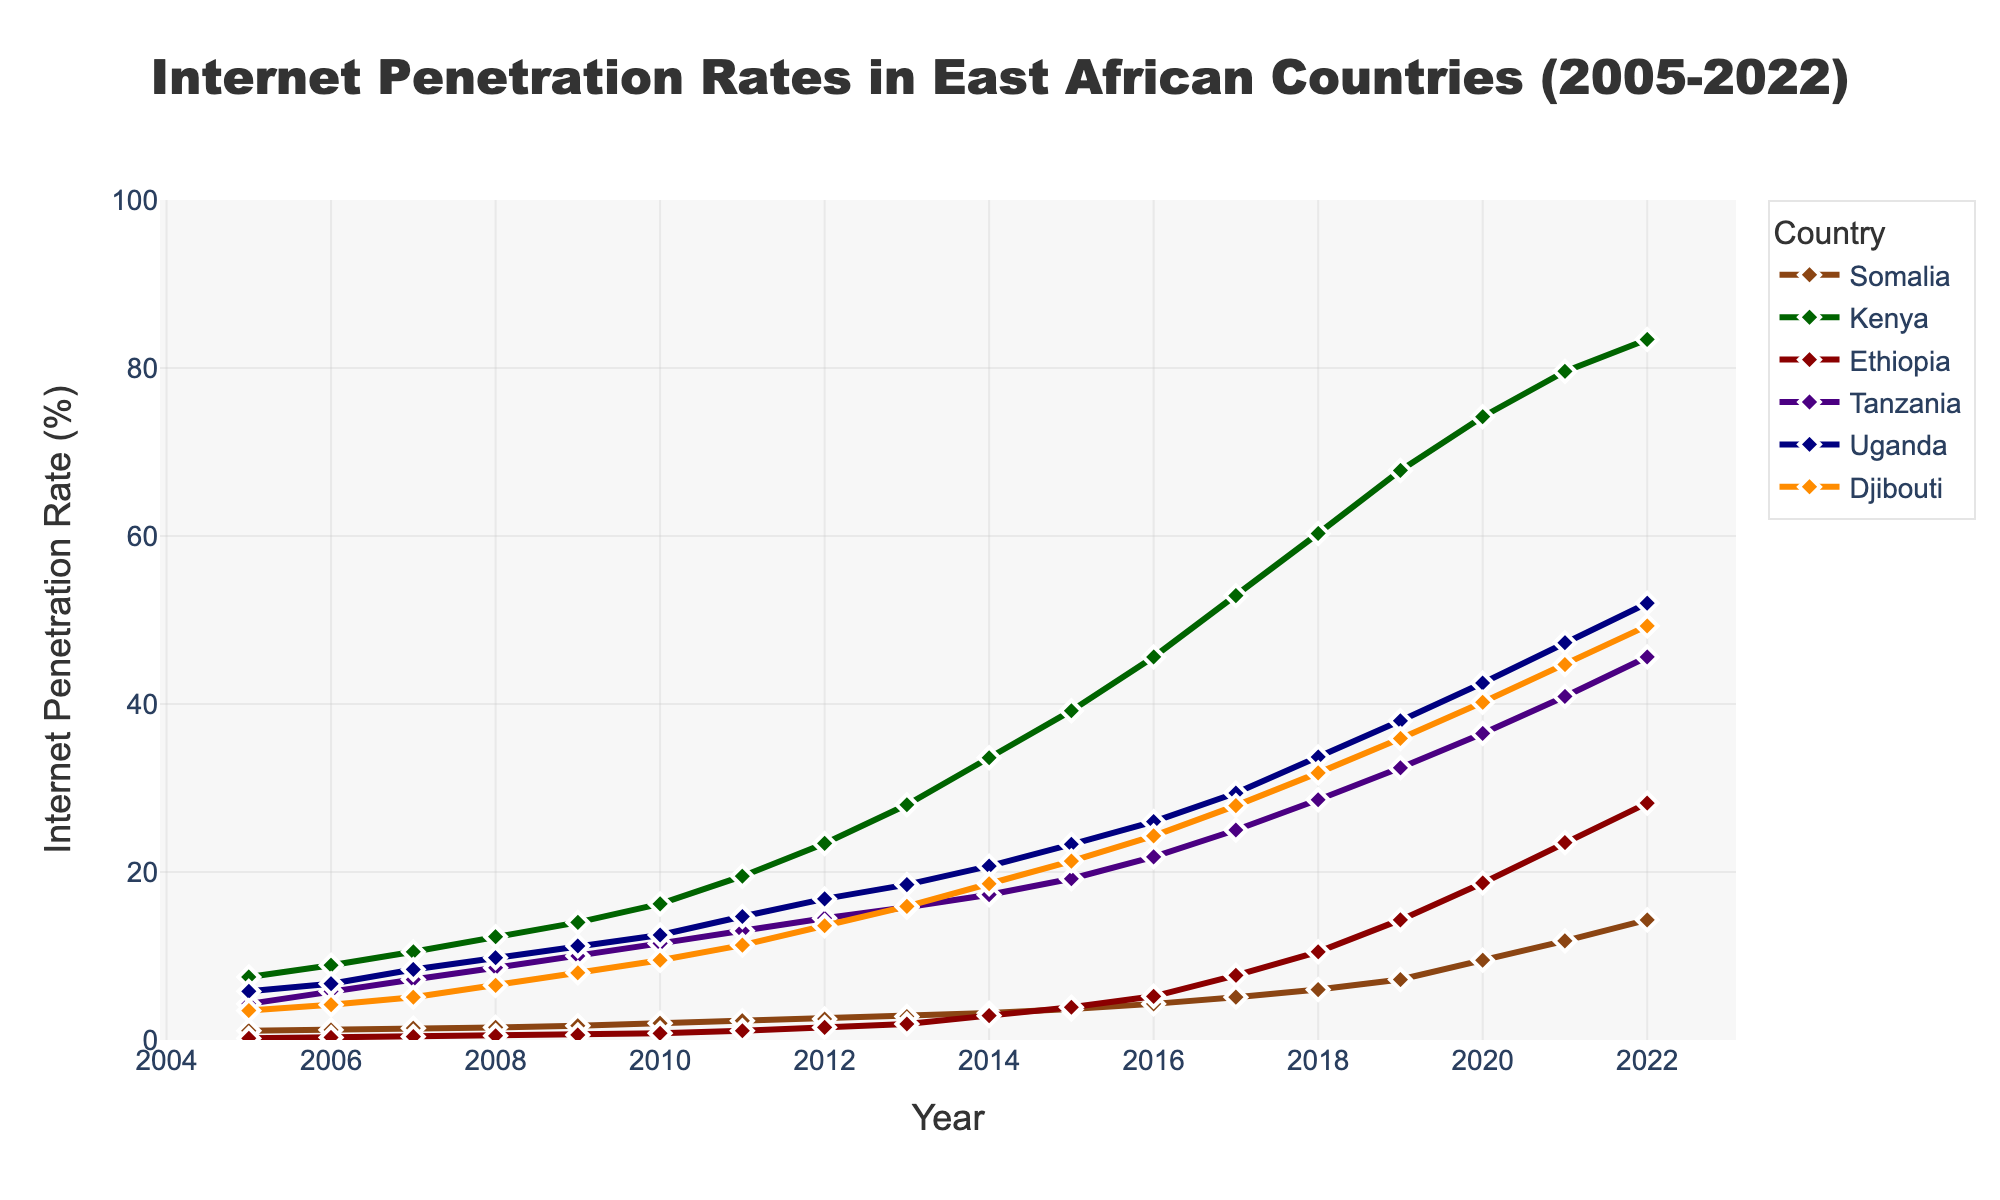What is the Internet penetration rate in Somalia in 2005? Identify the data point corresponding to Somalia in 2005 and look at its value.
Answer: 1.1% How did the Internet penetration rate in Kenya change between 2005 and 2022? Calculate the difference between the rate in 2022 and the rate in 2005 for Kenya by referring to the values at these years.
Answer: 75.9% Which country had the highest Internet penetration rate in 2022? Compare the Internet penetration rates of all countries in 2022. The country with the highest rate will be the answer.
Answer: Kenya By how much did the internet penetration rate in Ethiopia increase from 2005 to 2010? Subtract the penetration rate of Ethiopia in 2005 from its rate in 2010.
Answer: 0.6% What's the average Internet penetration rate of Djibouti from 2005 to 2022? To find the average, sum the Internet penetration rates of Djibouti from 2005 to 2022 and divide by the number of years. The values are \[3.5, 4.2, 5.1, 6.5, 8.0, 9.5, 11.3, 13.6, 15.9, 18.6, 21.3, 24.3, 27.9, 31.8, 35.9, 40.2, 44.7, 49.3\], and their sum is 347 result (347/18).
Answer: 19.28% Which country had the lowest Internet penetration rate in 2015? Compare the Internet penetration rates of all countries in 2015 and identify the lowest value.
Answer: Ethiopia Compare the Internet penetration increments from 2010 to 2015 for Tanzania and Uganda. Which country had a larger increase? Calculate the difference in Internet penetration for Tanzania and Uganda from 2010 to 2015, then compare these two differences. Tanzania's increase is 19.2-11.5=7.7% and Uganda's is 23.3-12.5=10.8%.
Answer: Uganda What was the general trend of Internet penetration in Somalia from 2005 to 2022? Observe the graph line for Somalia and describe whether it is generally increasing, decreasing, or stable.
Answer: Increasing Which country showed the most consistent year-on-year growth in Internet penetration from 2005 to 2022? Analyze the slopes of the lines for all countries and determine which one has the least variation year-on-year.
Answer: Kenya What is the difference in Internet penetration rates between Tanzania and Uganda in 2020? Subtract the Internet penetration rate of Tanzania for 2020 from that of Uganda in 2020.
Answer: 6% What year did Ethiopia surpass a 10% internet penetration rate, and how significant was this achievement in comparison to Djibouti's rate at the same time? Locate the year Ethiopia surpassed 10%, which is 2018. Compare it to Djibouti at this time, which is 31.8%, showing Djibouti was significantly higher.
Answer: 2018, 21.3% higher 